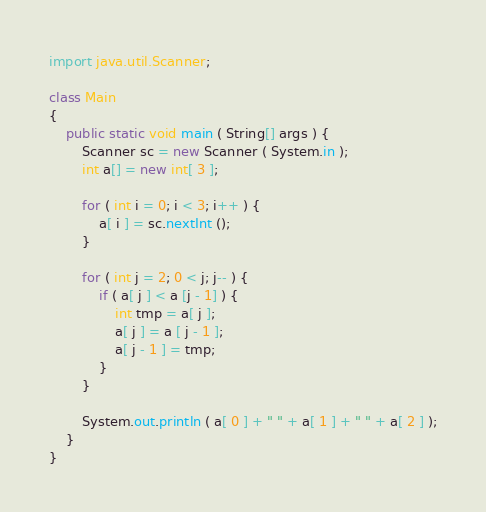<code> <loc_0><loc_0><loc_500><loc_500><_Java_>import java.util.Scanner;

class Main
{
	public static void main ( String[] args ) {
		Scanner sc = new Scanner ( System.in );
		int a[] = new int[ 3 ];

		for ( int i = 0; i < 3; i++ ) {
			a[ i ] = sc.nextInt ();
		}

		for ( int j = 2; 0 < j; j-- ) {
			if ( a[ j ] < a [j - 1] ) {
				int tmp = a[ j ];
				a[ j ] = a [ j - 1 ];
				a[ j - 1 ] = tmp;
			}
		}

		System.out.println ( a[ 0 ] + " " + a[ 1 ] + " " + a[ 2 ] );
	}
}</code> 